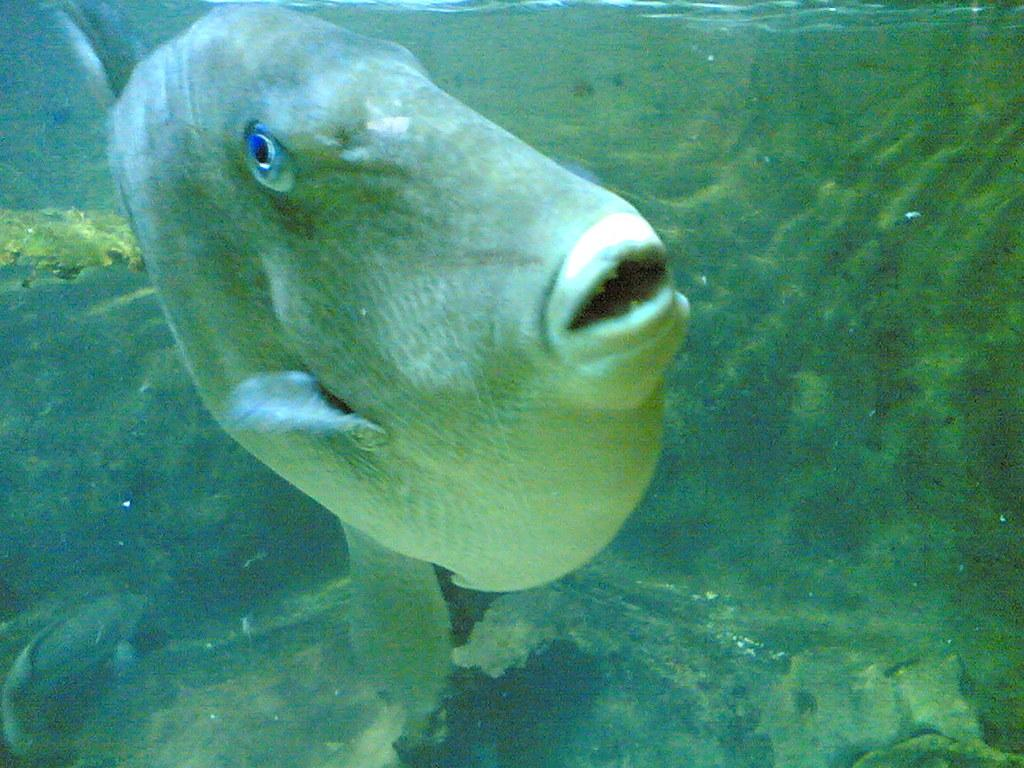What type of animal is in the image? There is a fish in the image. Where is the fish located? The fish is in the water. How many feet can be seen touching the water in the image? There are no feet visible in the image, as it features a fish in the water. What type of branch can be seen growing from the fish in the image? There is no branch present in the image, as it features a fish in the water. 